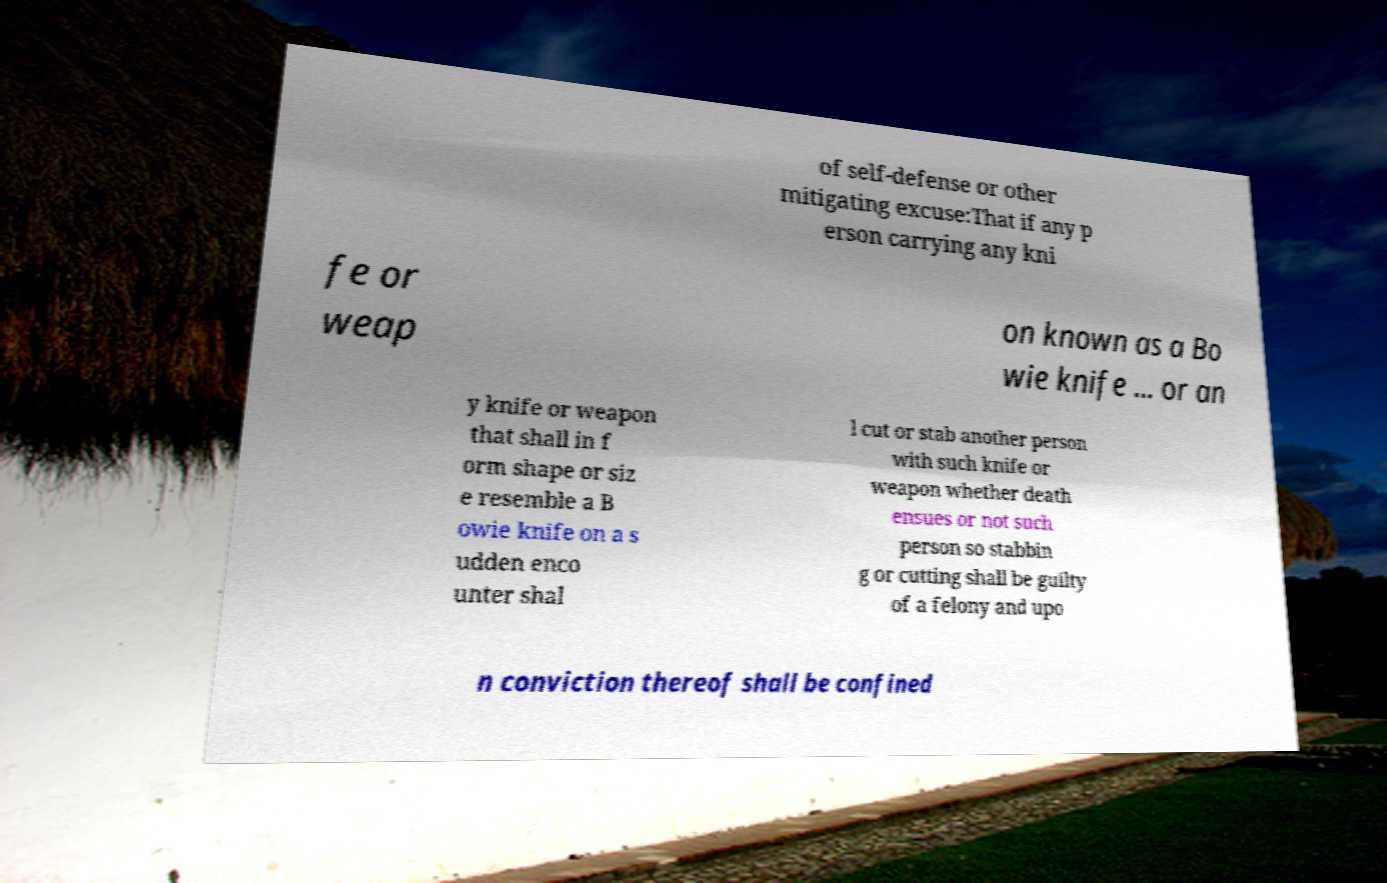For documentation purposes, I need the text within this image transcribed. Could you provide that? of self-defense or other mitigating excuse:That if any p erson carrying any kni fe or weap on known as a Bo wie knife ... or an y knife or weapon that shall in f orm shape or siz e resemble a B owie knife on a s udden enco unter shal l cut or stab another person with such knife or weapon whether death ensues or not such person so stabbin g or cutting shall be guilty of a felony and upo n conviction thereof shall be confined 